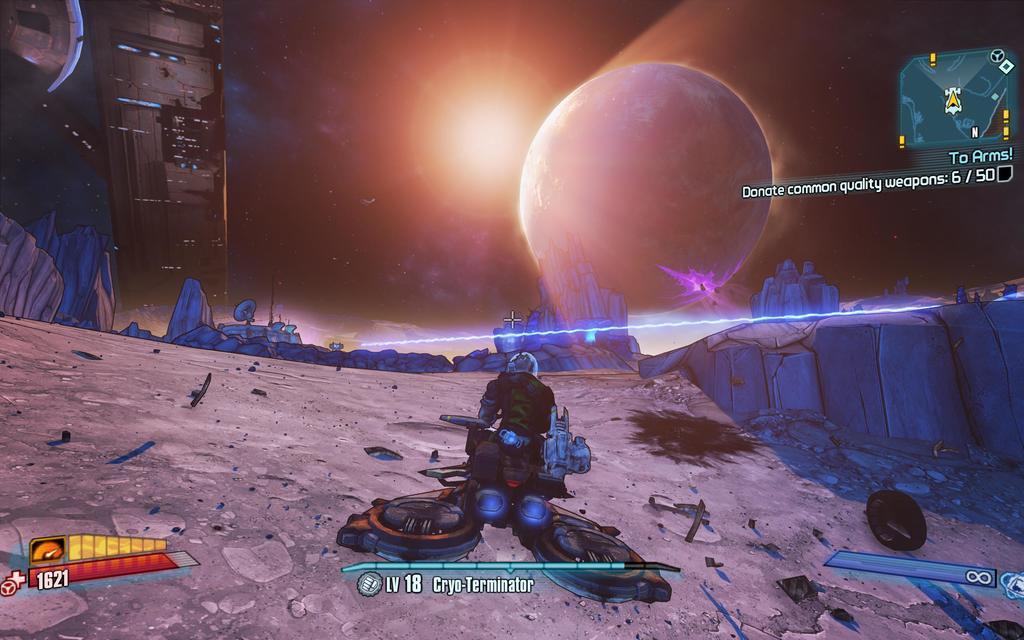Could you give a brief overview of what you see in this image? It is a screenshot of a game. 